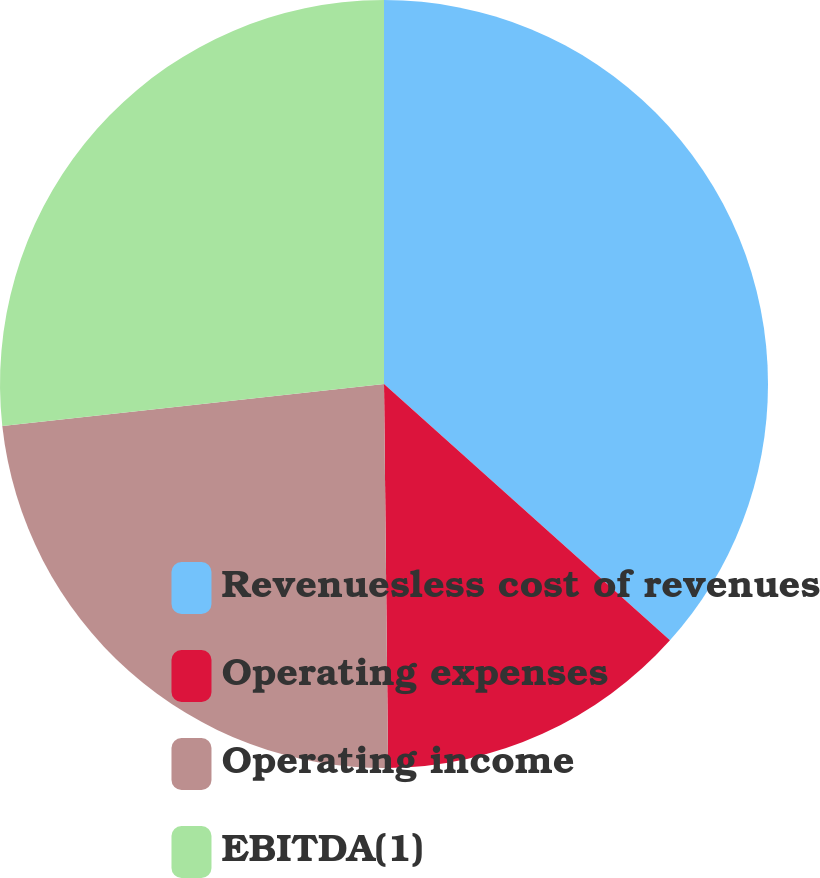<chart> <loc_0><loc_0><loc_500><loc_500><pie_chart><fcel>Revenuesless cost of revenues<fcel>Operating expenses<fcel>Operating income<fcel>EBITDA(1)<nl><fcel>36.63%<fcel>13.2%<fcel>23.43%<fcel>26.74%<nl></chart> 